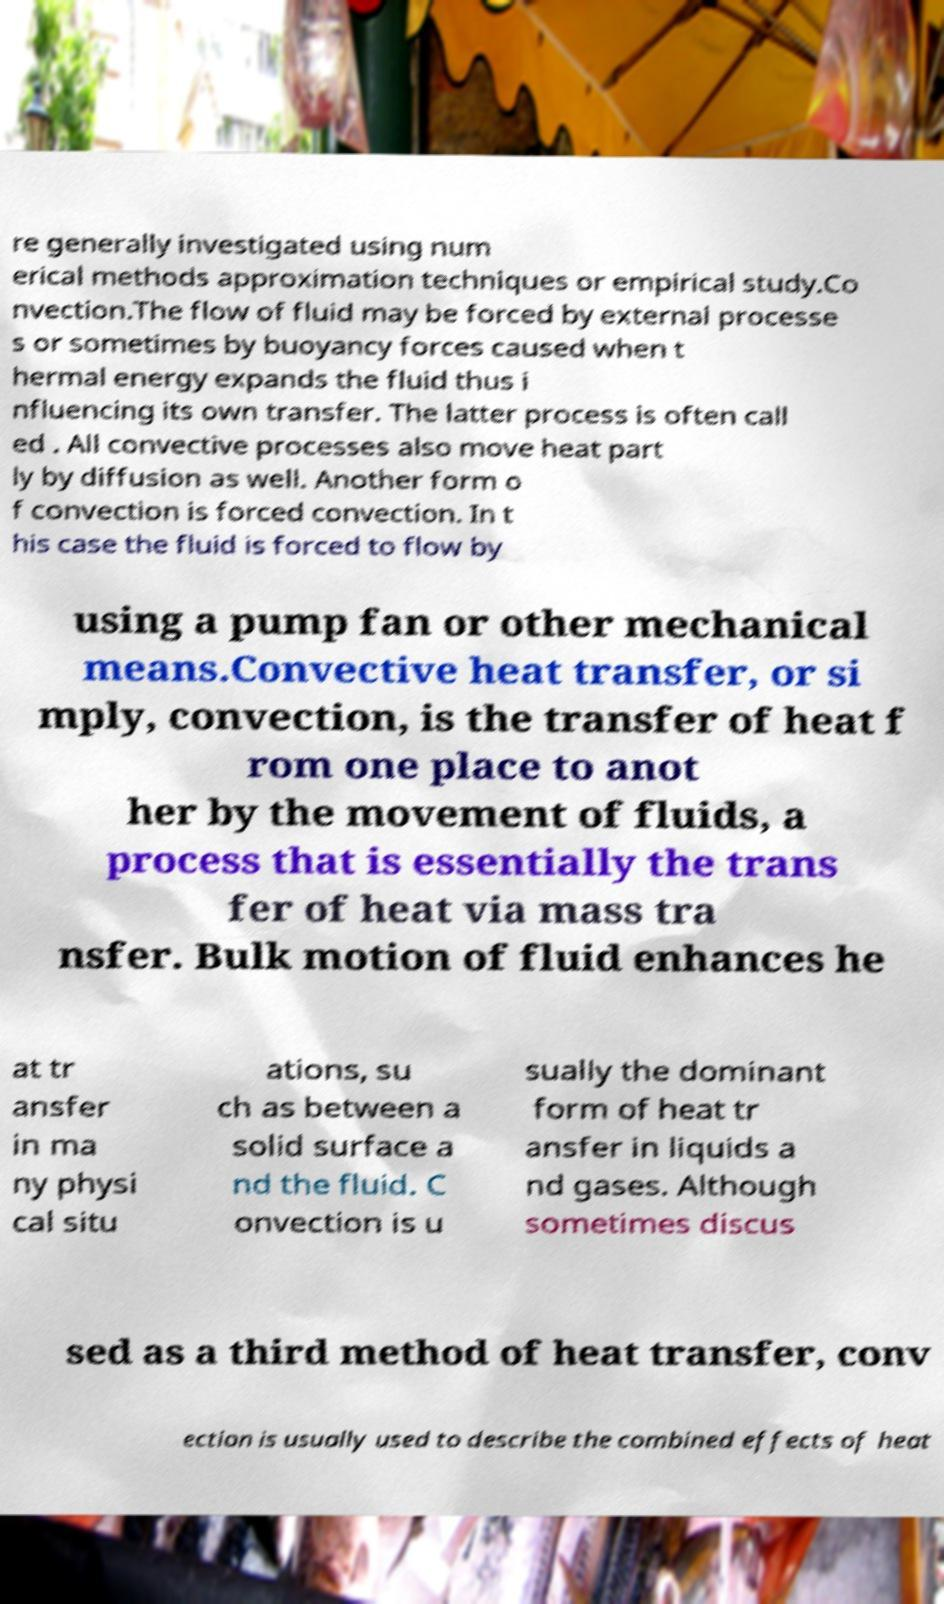Can you read and provide the text displayed in the image?This photo seems to have some interesting text. Can you extract and type it out for me? re generally investigated using num erical methods approximation techniques or empirical study.Co nvection.The flow of fluid may be forced by external processe s or sometimes by buoyancy forces caused when t hermal energy expands the fluid thus i nfluencing its own transfer. The latter process is often call ed . All convective processes also move heat part ly by diffusion as well. Another form o f convection is forced convection. In t his case the fluid is forced to flow by using a pump fan or other mechanical means.Convective heat transfer, or si mply, convection, is the transfer of heat f rom one place to anot her by the movement of fluids, a process that is essentially the trans fer of heat via mass tra nsfer. Bulk motion of fluid enhances he at tr ansfer in ma ny physi cal situ ations, su ch as between a solid surface a nd the fluid. C onvection is u sually the dominant form of heat tr ansfer in liquids a nd gases. Although sometimes discus sed as a third method of heat transfer, conv ection is usually used to describe the combined effects of heat 